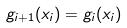<formula> <loc_0><loc_0><loc_500><loc_500>g _ { i + 1 } ( x _ { i } ) = g _ { i } ( x _ { i } )</formula> 